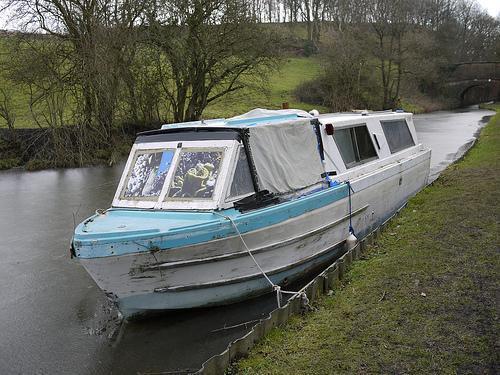How many boats are in the photo?
Give a very brief answer. 1. 